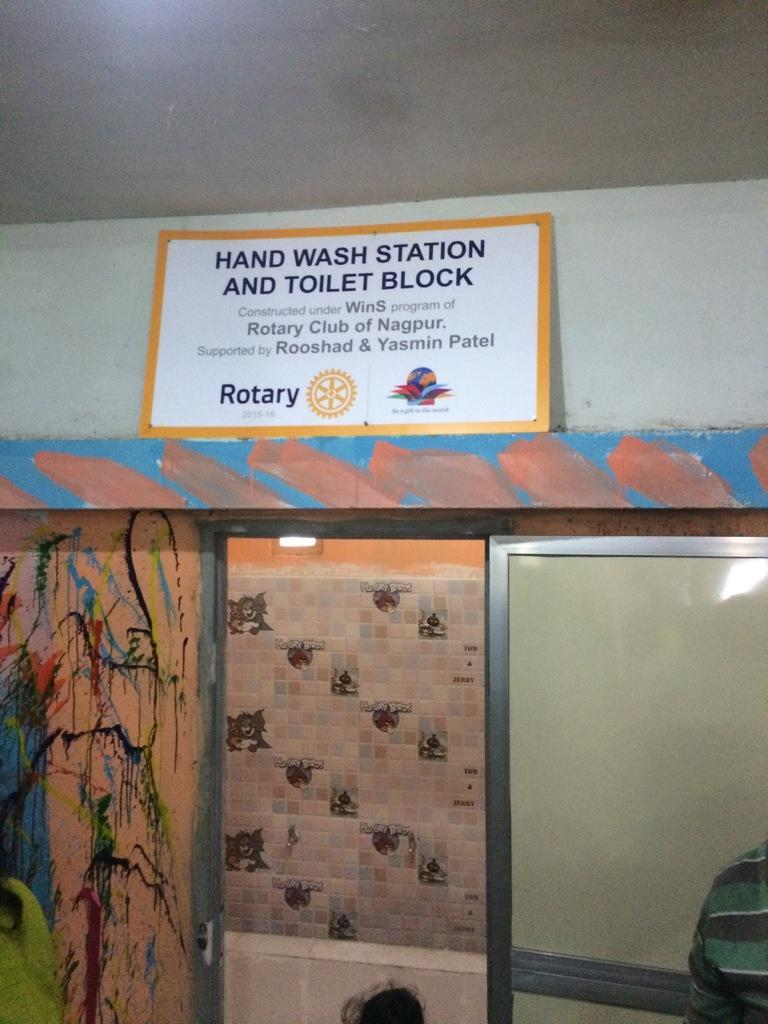What is the main structure in the center of the image? There is a door in the center of the image. What else can be seen in the image besides the door? There is a wall, a placard, and a ceiling visible in the image. Is there anyone present in the image? Yes, there is a person on the right side of the image. What type of religious symbol is present on the placard in the image? There is no religious symbol present on the placard in the image. How does the person in the image cover their face? The person in the image is not covering their face, and there is no indication that they are doing so. 